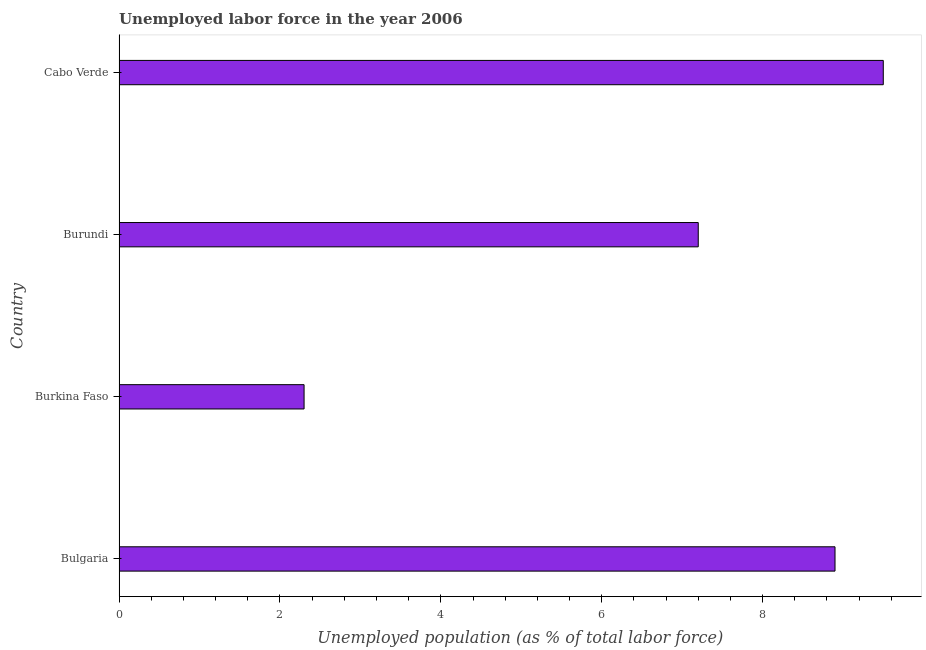Does the graph contain any zero values?
Your answer should be very brief. No. What is the title of the graph?
Make the answer very short. Unemployed labor force in the year 2006. What is the label or title of the X-axis?
Make the answer very short. Unemployed population (as % of total labor force). What is the label or title of the Y-axis?
Your response must be concise. Country. What is the total unemployed population in Bulgaria?
Provide a succinct answer. 8.9. Across all countries, what is the maximum total unemployed population?
Offer a very short reply. 9.5. Across all countries, what is the minimum total unemployed population?
Provide a succinct answer. 2.3. In which country was the total unemployed population maximum?
Offer a terse response. Cabo Verde. In which country was the total unemployed population minimum?
Your response must be concise. Burkina Faso. What is the sum of the total unemployed population?
Ensure brevity in your answer.  27.9. What is the average total unemployed population per country?
Give a very brief answer. 6.97. What is the median total unemployed population?
Offer a terse response. 8.05. In how many countries, is the total unemployed population greater than 8.8 %?
Provide a short and direct response. 2. What is the ratio of the total unemployed population in Bulgaria to that in Burundi?
Provide a succinct answer. 1.24. Is the total unemployed population in Bulgaria less than that in Cabo Verde?
Ensure brevity in your answer.  Yes. What is the difference between the highest and the second highest total unemployed population?
Keep it short and to the point. 0.6. Is the sum of the total unemployed population in Burundi and Cabo Verde greater than the maximum total unemployed population across all countries?
Keep it short and to the point. Yes. What is the difference between the highest and the lowest total unemployed population?
Your answer should be compact. 7.2. In how many countries, is the total unemployed population greater than the average total unemployed population taken over all countries?
Provide a short and direct response. 3. What is the Unemployed population (as % of total labor force) in Bulgaria?
Your response must be concise. 8.9. What is the Unemployed population (as % of total labor force) of Burkina Faso?
Offer a terse response. 2.3. What is the Unemployed population (as % of total labor force) of Burundi?
Make the answer very short. 7.2. What is the difference between the Unemployed population (as % of total labor force) in Bulgaria and Burkina Faso?
Ensure brevity in your answer.  6.6. What is the difference between the Unemployed population (as % of total labor force) in Bulgaria and Cabo Verde?
Provide a succinct answer. -0.6. What is the ratio of the Unemployed population (as % of total labor force) in Bulgaria to that in Burkina Faso?
Keep it short and to the point. 3.87. What is the ratio of the Unemployed population (as % of total labor force) in Bulgaria to that in Burundi?
Your answer should be compact. 1.24. What is the ratio of the Unemployed population (as % of total labor force) in Bulgaria to that in Cabo Verde?
Ensure brevity in your answer.  0.94. What is the ratio of the Unemployed population (as % of total labor force) in Burkina Faso to that in Burundi?
Your response must be concise. 0.32. What is the ratio of the Unemployed population (as % of total labor force) in Burkina Faso to that in Cabo Verde?
Give a very brief answer. 0.24. What is the ratio of the Unemployed population (as % of total labor force) in Burundi to that in Cabo Verde?
Ensure brevity in your answer.  0.76. 